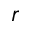Convert formula to latex. <formula><loc_0><loc_0><loc_500><loc_500>r</formula> 